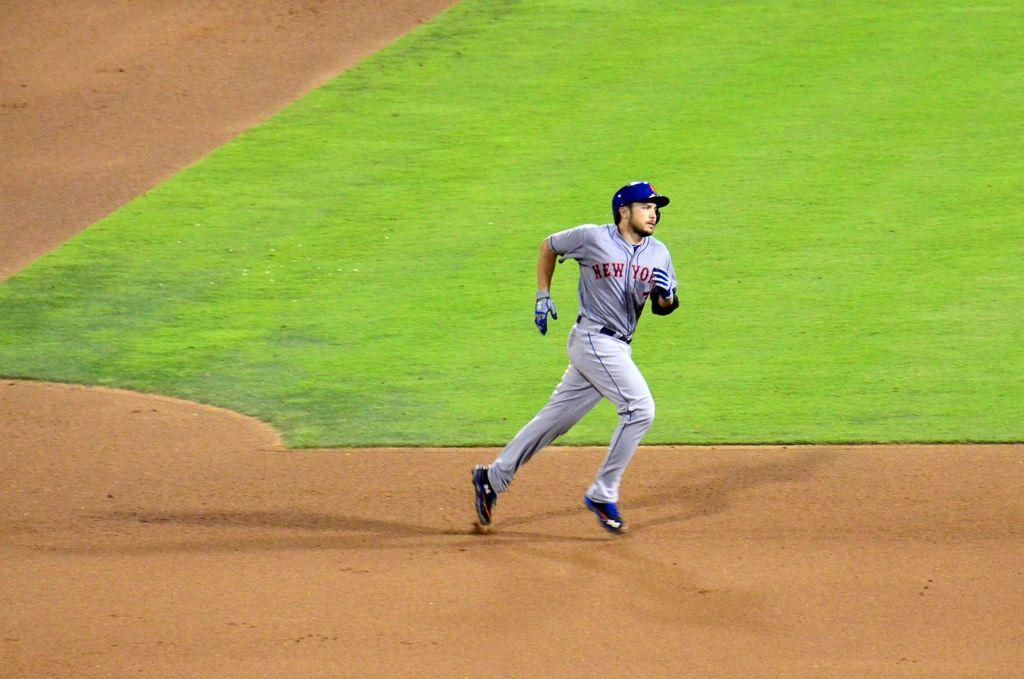<image>
Create a compact narrative representing the image presented. A baseball player in a grey strip with New York on the front runs between the bases. 